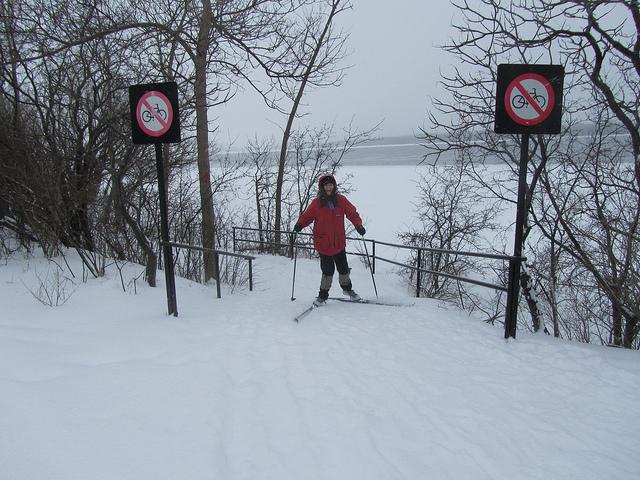What color are the signs on top?
Quick response, please. Black. Can people ride bikes here?
Be succinct. No. Is the woman OK to use her mode of travel in this area?
Short answer required. Yes. What color is her coat?
Keep it brief. Red. 